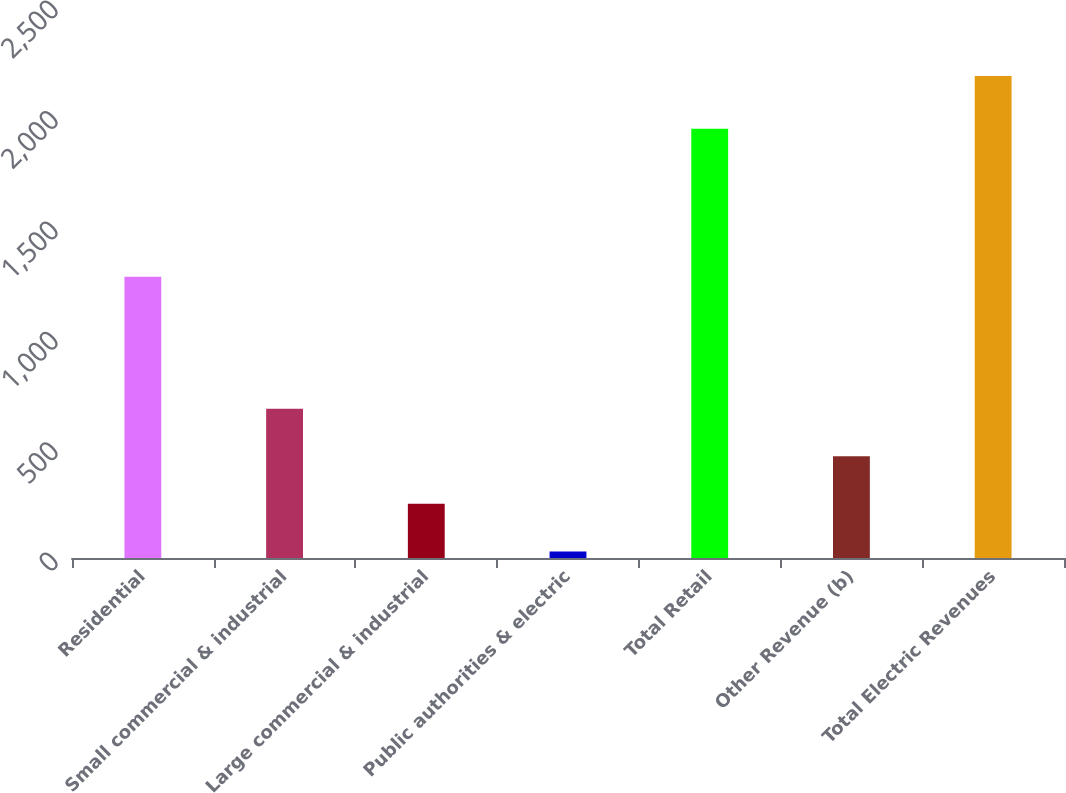Convert chart. <chart><loc_0><loc_0><loc_500><loc_500><bar_chart><fcel>Residential<fcel>Small commercial & industrial<fcel>Large commercial & industrial<fcel>Public authorities & electric<fcel>Total Retail<fcel>Other Revenue (b)<fcel>Total Electric Revenues<nl><fcel>1274<fcel>675.9<fcel>245.3<fcel>30<fcel>1944<fcel>460.6<fcel>2183<nl></chart> 